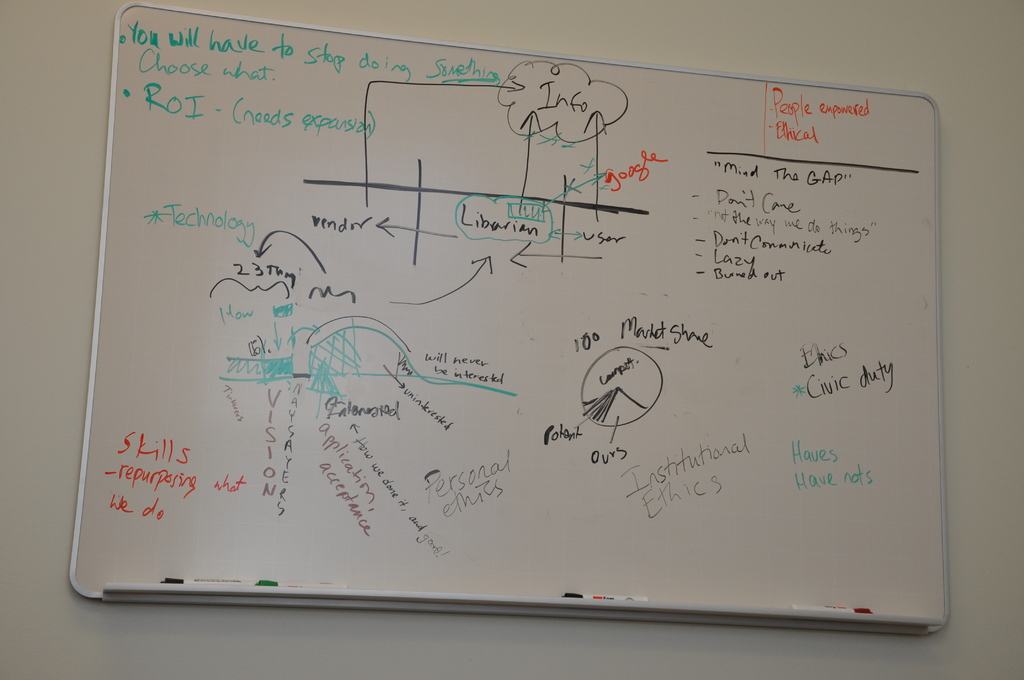What does the diagram with the bridge between the 'Librarian' and 'User' represent in this context? The bridge between the 'Librarian' and 'User' likely symbolizes the effort to enhance communications and interactions between different stakeholders. In this context, it may represent an initiative to strengthen the relationship or improve the flow of information between service providers (like librarians) and end-users, which is essential for effective service delivery and user satisfaction. 